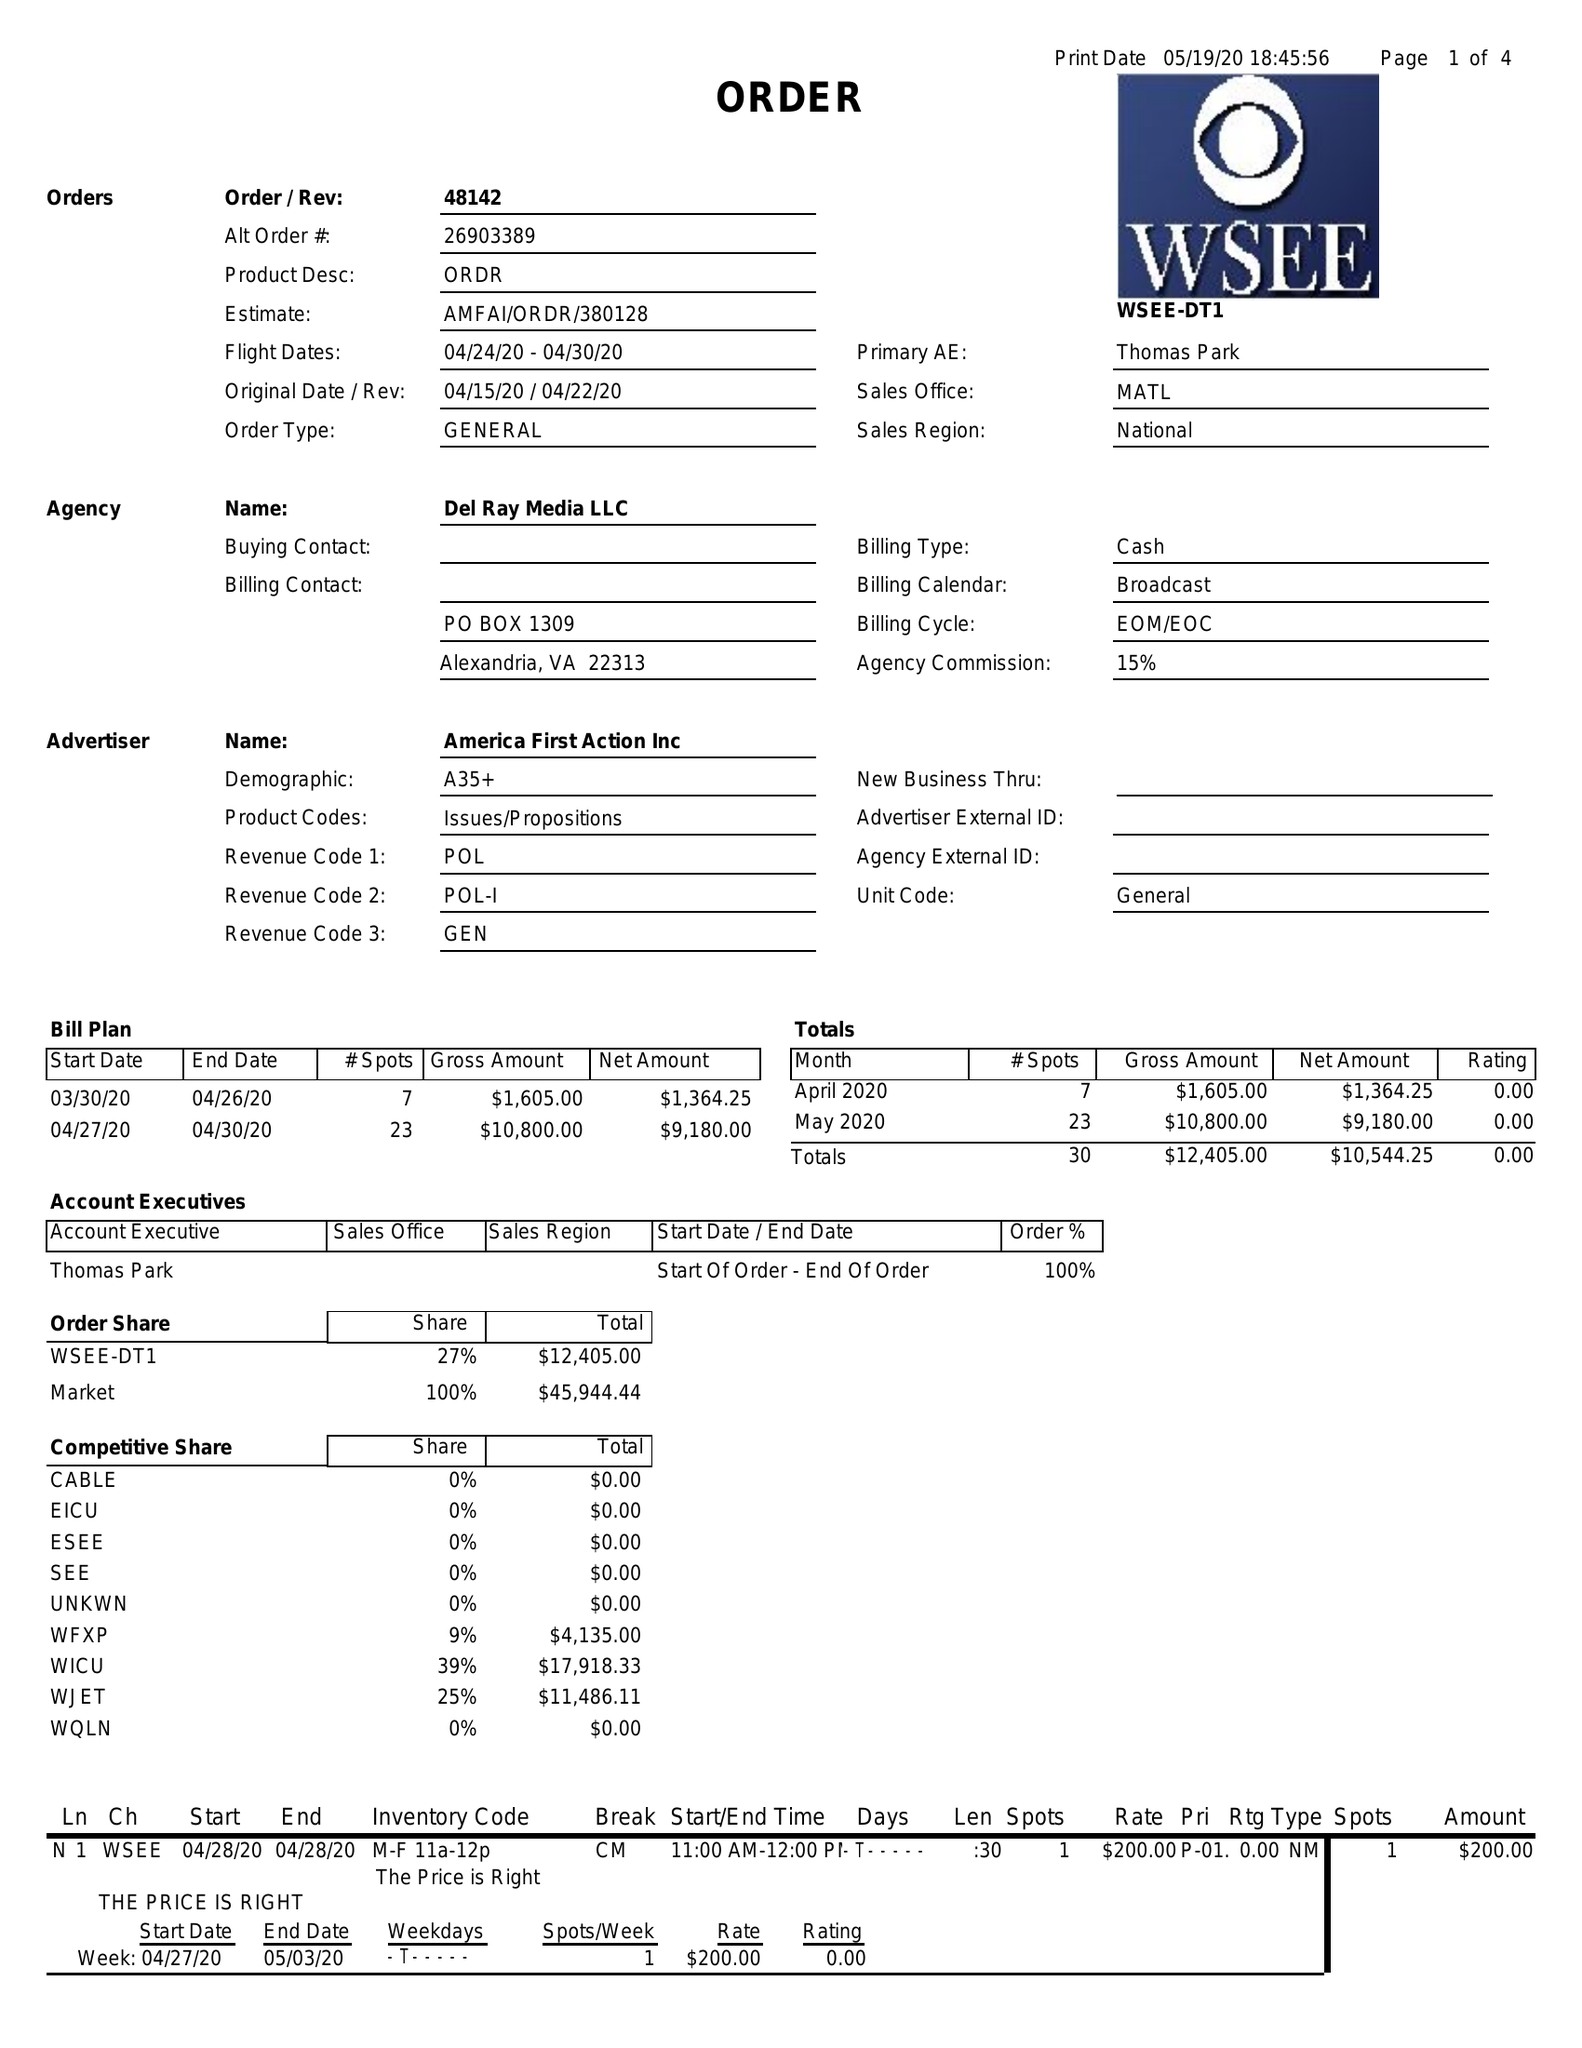What is the value for the advertiser?
Answer the question using a single word or phrase. AMERICA FIRST ACTION INC 